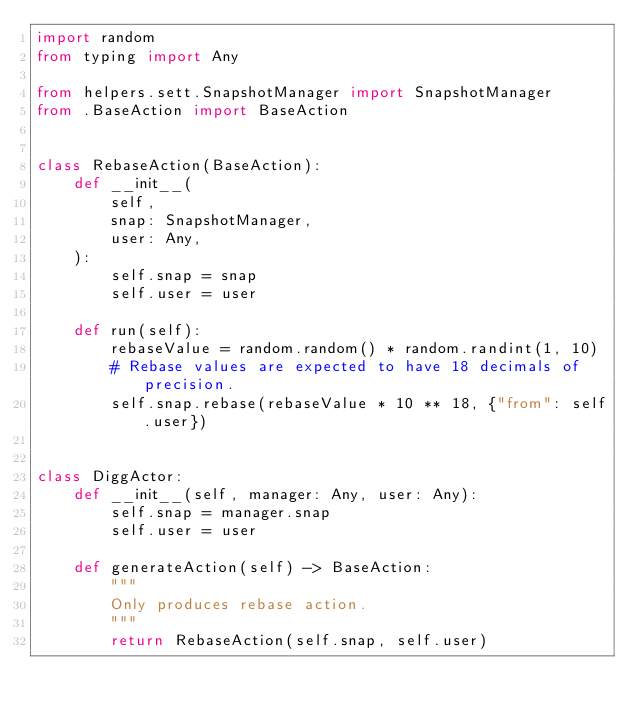Convert code to text. <code><loc_0><loc_0><loc_500><loc_500><_Python_>import random
from typing import Any

from helpers.sett.SnapshotManager import SnapshotManager
from .BaseAction import BaseAction


class RebaseAction(BaseAction):
    def __init__(
        self,
        snap: SnapshotManager,
        user: Any,
    ):
        self.snap = snap
        self.user = user

    def run(self):
        rebaseValue = random.random() * random.randint(1, 10)
        # Rebase values are expected to have 18 decimals of precision.
        self.snap.rebase(rebaseValue * 10 ** 18, {"from": self.user})


class DiggActor:
    def __init__(self, manager: Any, user: Any):
        self.snap = manager.snap
        self.user = user

    def generateAction(self) -> BaseAction:
        """
        Only produces rebase action.
        """
        return RebaseAction(self.snap, self.user)
</code> 